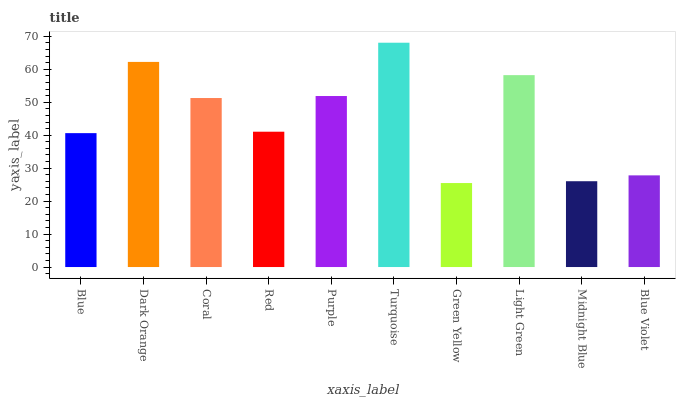Is Green Yellow the minimum?
Answer yes or no. Yes. Is Turquoise the maximum?
Answer yes or no. Yes. Is Dark Orange the minimum?
Answer yes or no. No. Is Dark Orange the maximum?
Answer yes or no. No. Is Dark Orange greater than Blue?
Answer yes or no. Yes. Is Blue less than Dark Orange?
Answer yes or no. Yes. Is Blue greater than Dark Orange?
Answer yes or no. No. Is Dark Orange less than Blue?
Answer yes or no. No. Is Coral the high median?
Answer yes or no. Yes. Is Red the low median?
Answer yes or no. Yes. Is Blue Violet the high median?
Answer yes or no. No. Is Blue Violet the low median?
Answer yes or no. No. 